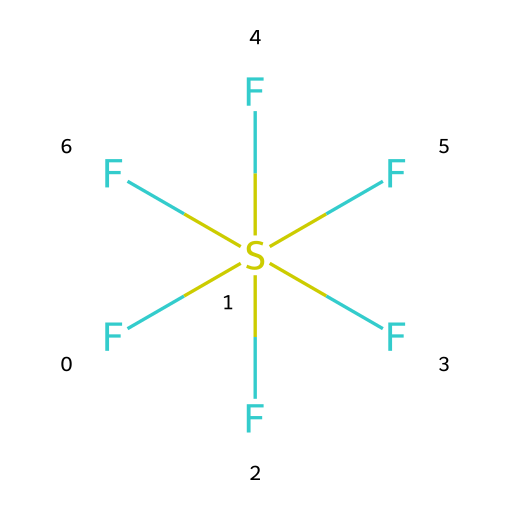What is the molecular formula of sulfur hexafluoride? The chemical structure shows one sulfur atom (S) and six fluorine atoms (F), which can be combined to give the molecular formula SF6.
Answer: SF6 How many fluorine atoms are present in sulfur hexafluoride? From the visual structure, there are six fluorine atoms attached to the sulfur atom, which can be counted directly.
Answer: 6 What is the role of sulfur hexafluoride in audio post-production? Sulfur hexafluoride is known to lower the pitch of the voice, creating a deep voice effect when inhaled, due to its density compared to air.
Answer: deep voice What is the state of sulfur hexafluoride at room temperature? The structure indicates that sulfur hexafluoride is a gas at room temperature, as it is typically used as a non-toxic inhalable gas in various applications.
Answer: gas Why does sulfur hexafluoride create a deep voice effect? The high molecular weight and density of sulfur hexafluoride result in sound waves traveling slower, which lowers the pitch of the voice when the gas is inhaled.
Answer: density Is sulfur hexafluoride a polar or non-polar molecule? The symmetrical structure of sulfur hexafluoride with equal F-S bonds means that it does not have a net dipole moment, making it a non-polar molecule.
Answer: non-polar 